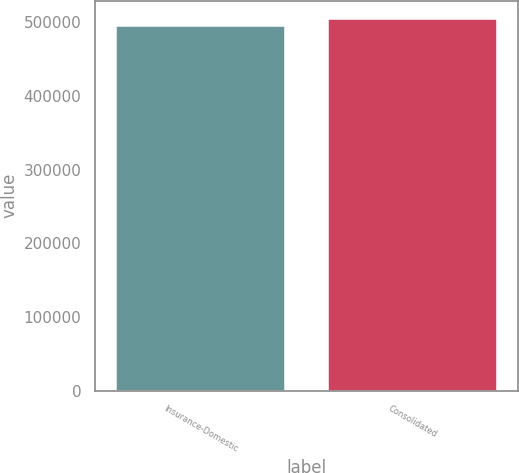Convert chart to OTSL. <chart><loc_0><loc_0><loc_500><loc_500><bar_chart><fcel>Insurance-Domestic<fcel>Consolidated<nl><fcel>495082<fcel>503694<nl></chart> 